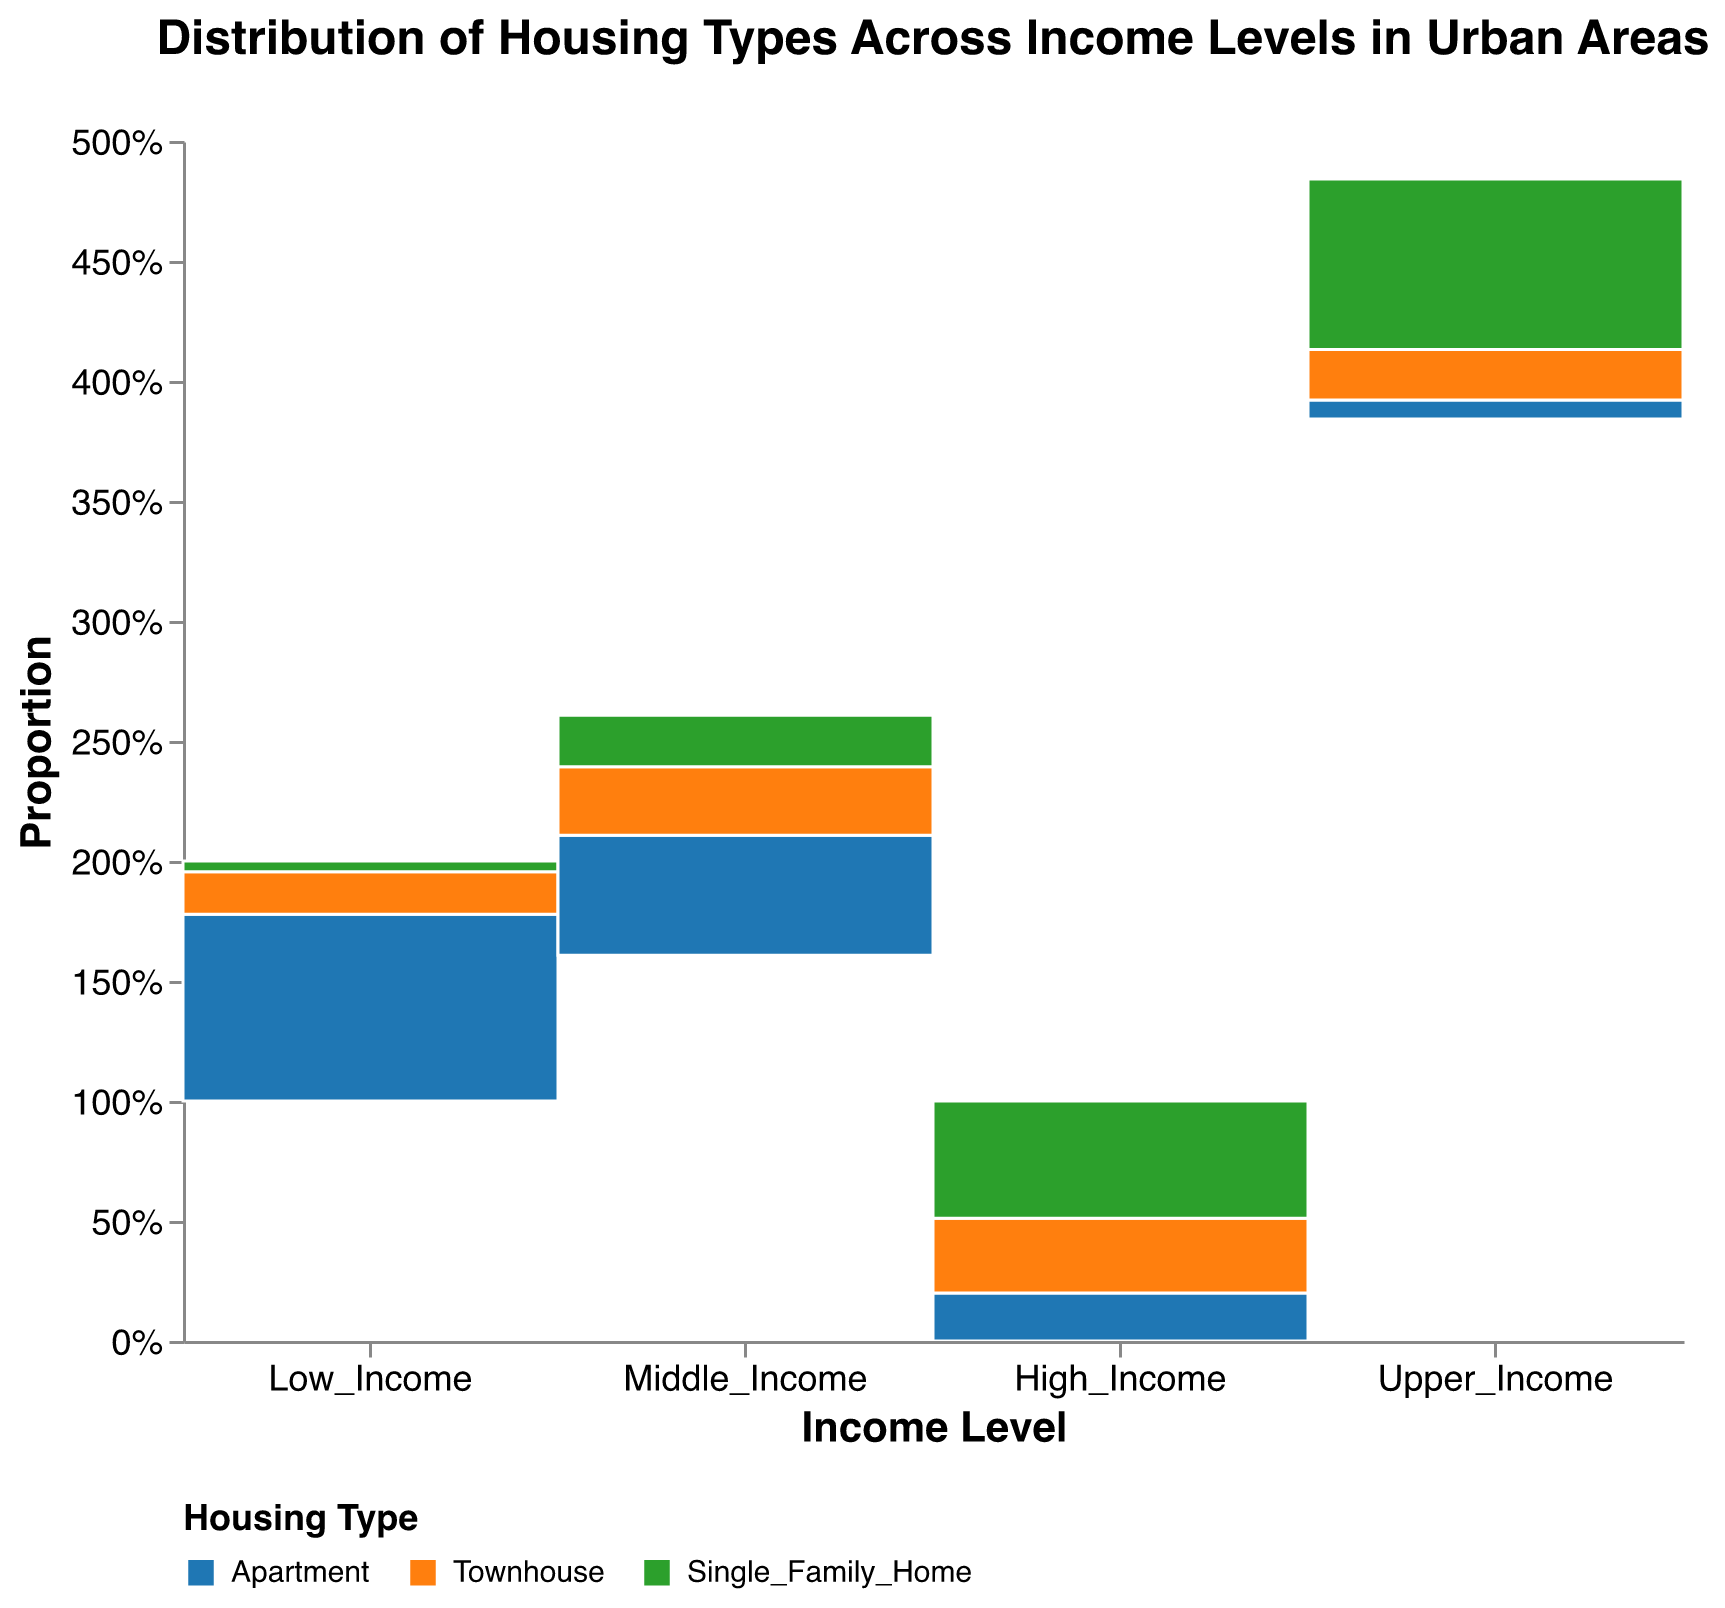What's the title of the plot? The title is displayed at the top center of the plot and reads "Distribution of Housing Types Across Income Levels in Urban Areas".
Answer: Distribution of Housing Types Across Income Levels in Urban Areas What are the axis labels? The x-axis label is "Income Level" and the y-axis label is "Proportion".
Answer: Income Level and Proportion What is the most common housing type among Low Income groups? The largest segment in the Low Income group corresponds to "Apartment", indicated by the largest area in the respective section.
Answer: Apartment Which income level has the highest proportion of Single Family Homes? To find the income level with the highest proportion of Single Family Homes, compare the sizes of the Single Family Home segments across the different income levels. The largest segment is in the "Upper Income" group.
Answer: Upper Income How does the proportion of Townhouses in the Middle Income group compare to the High Income group? Observe and compare the sizes of the Townhouse segments in the Middle Income and High Income groups. The Middle Income group has a larger Townhouse segment than the High Income group.
Answer: Larger in the Middle Income group Which income level has the lowest proportion of Apartments? Identify the smallest Apartment segment among the different income levels. The smallest Apartment segment is found in the "Upper Income" group.
Answer: Upper Income In which income level is the distribution between housing types the most balanced? Check for the group where the sizes of the segments (Apartment, Townhouse, Single Family Home) are the most similar. The High Income group shows a more balanced distribution among the three housing types.
Answer: High Income What percentage of the Low Income group lives in Single Family Homes? In the Low Income group, the Single Family Home section takes up a small fraction. Calculate it by the fractional segment (200/4500) and multiply by 100 for percentage. This fraction is approximately 4.44%.
Answer: 4.44% Are there more Townhouses or Single Family Homes in the Middle Income group? Compare the sizes of the Townhouse and Single Family Home segments in the Middle Income group. The Townhouse segment is larger.
Answer: Townhouses What's the overall trend in housing type preferences as income levels rise? Observe how the sizes of each housing type segment change across increasing income levels. Generally, the proportion of Single Family Homes increases, while the proportion of Apartments decreases with rising income levels.
Answer: Increase in Single Family Homes, decrease in Apartments 